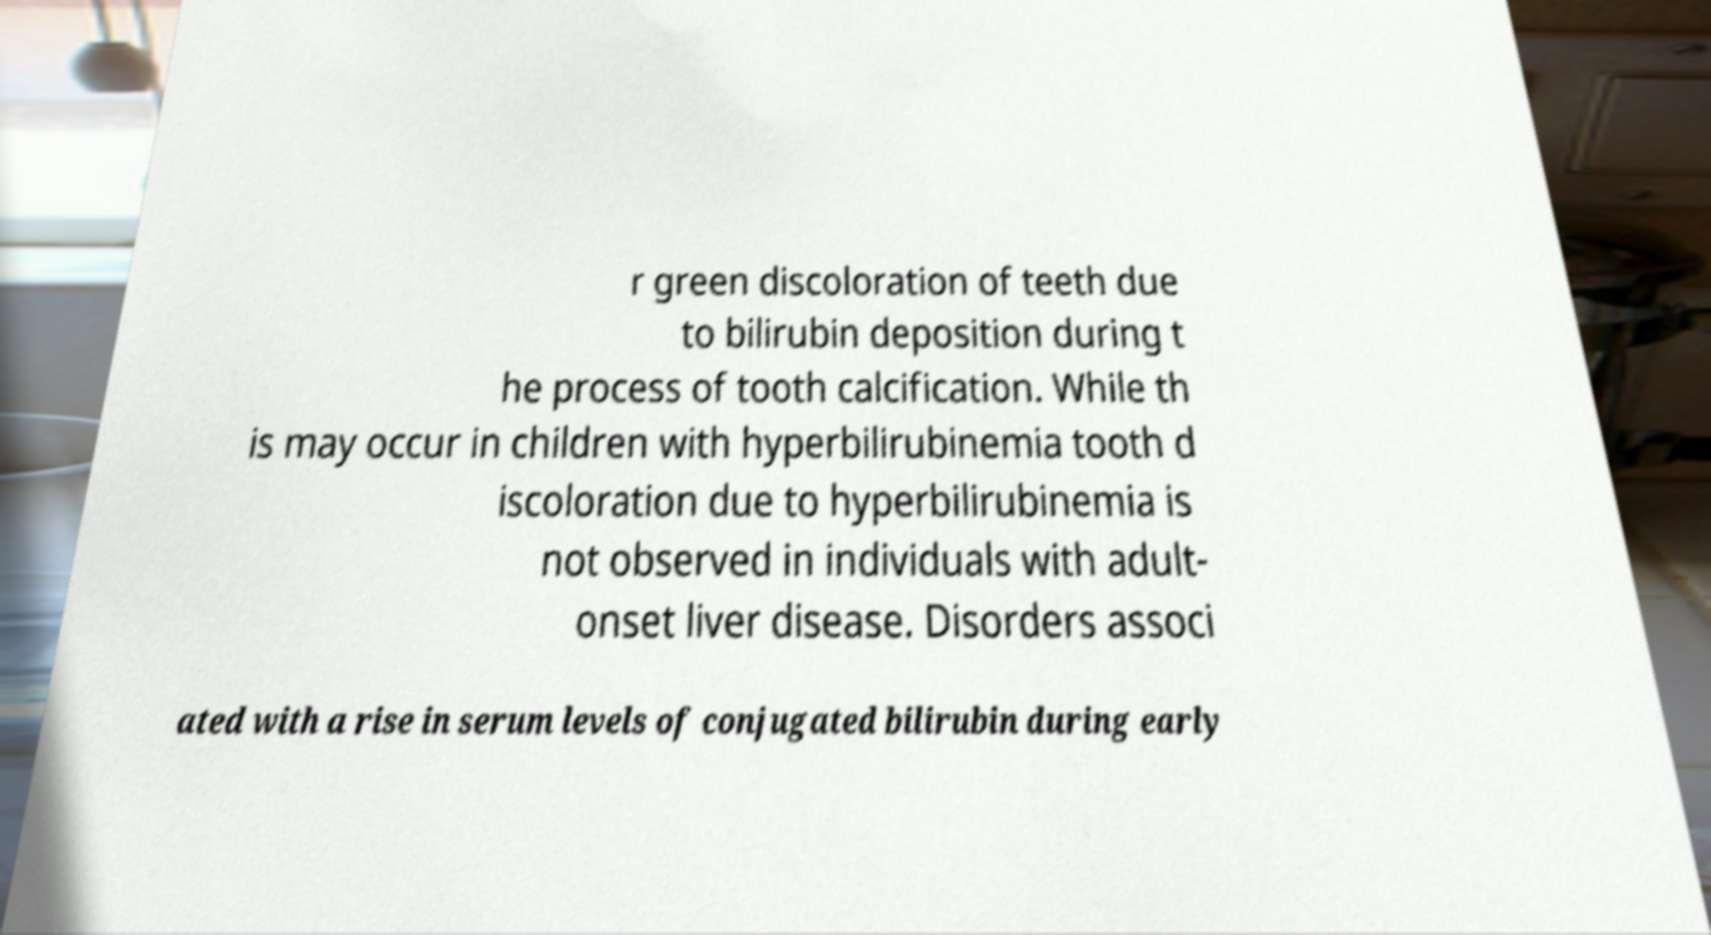For documentation purposes, I need the text within this image transcribed. Could you provide that? r green discoloration of teeth due to bilirubin deposition during t he process of tooth calcification. While th is may occur in children with hyperbilirubinemia tooth d iscoloration due to hyperbilirubinemia is not observed in individuals with adult- onset liver disease. Disorders associ ated with a rise in serum levels of conjugated bilirubin during early 